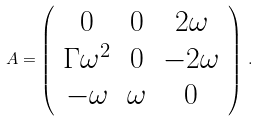<formula> <loc_0><loc_0><loc_500><loc_500>A = \left ( \begin{array} { c c c } 0 & 0 & 2 \omega \\ \Gamma \omega ^ { 2 } & 0 & - 2 \omega \\ - \omega & \omega & 0 \end{array} \right ) \, .</formula> 